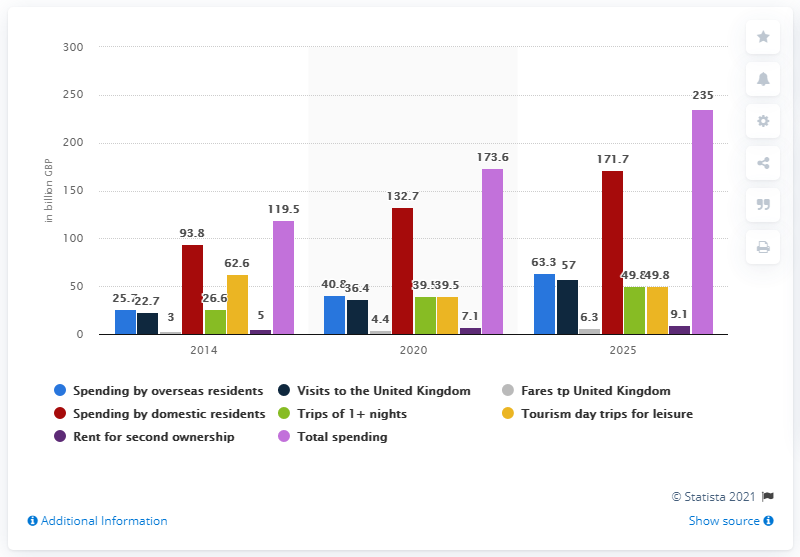What is the estimated spending by dometic residents in the UK by 2020?
 132.7 